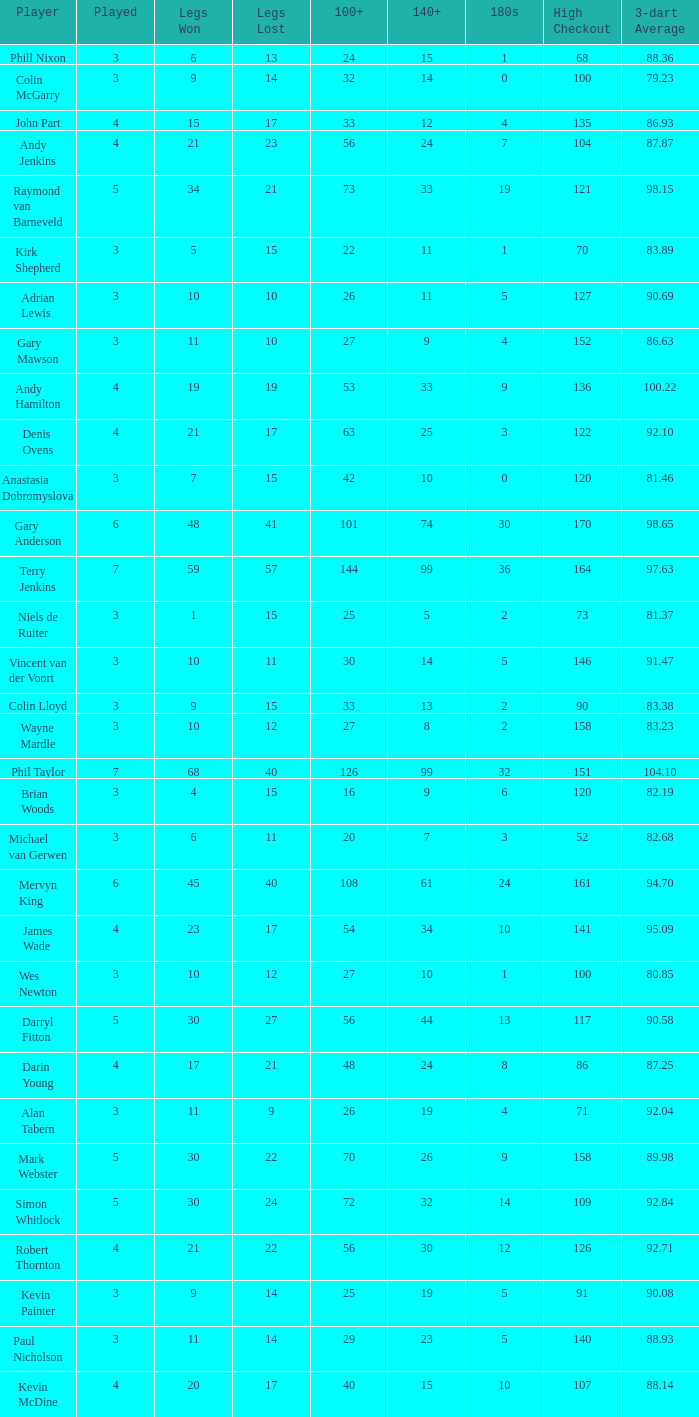What is the high checkout when Legs Won is smaller than 9, a 180s of 1, and a 3-dart Average larger than 88.36? None. Parse the table in full. {'header': ['Player', 'Played', 'Legs Won', 'Legs Lost', '100+', '140+', '180s', 'High Checkout', '3-dart Average'], 'rows': [['Phill Nixon', '3', '6', '13', '24', '15', '1', '68', '88.36'], ['Colin McGarry', '3', '9', '14', '32', '14', '0', '100', '79.23'], ['John Part', '4', '15', '17', '33', '12', '4', '135', '86.93'], ['Andy Jenkins', '4', '21', '23', '56', '24', '7', '104', '87.87'], ['Raymond van Barneveld', '5', '34', '21', '73', '33', '19', '121', '98.15'], ['Kirk Shepherd', '3', '5', '15', '22', '11', '1', '70', '83.89'], ['Adrian Lewis', '3', '10', '10', '26', '11', '5', '127', '90.69'], ['Gary Mawson', '3', '11', '10', '27', '9', '4', '152', '86.63'], ['Andy Hamilton', '4', '19', '19', '53', '33', '9', '136', '100.22'], ['Denis Ovens', '4', '21', '17', '63', '25', '3', '122', '92.10'], ['Anastasia Dobromyslova', '3', '7', '15', '42', '10', '0', '120', '81.46'], ['Gary Anderson', '6', '48', '41', '101', '74', '30', '170', '98.65'], ['Terry Jenkins', '7', '59', '57', '144', '99', '36', '164', '97.63'], ['Niels de Ruiter', '3', '1', '15', '25', '5', '2', '73', '81.37'], ['Vincent van der Voort', '3', '10', '11', '30', '14', '5', '146', '91.47'], ['Colin Lloyd', '3', '9', '15', '33', '13', '2', '90', '83.38'], ['Wayne Mardle', '3', '10', '12', '27', '8', '2', '158', '83.23'], ['Phil Taylor', '7', '68', '40', '126', '99', '32', '151', '104.10'], ['Brian Woods', '3', '4', '15', '16', '9', '6', '120', '82.19'], ['Michael van Gerwen', '3', '6', '11', '20', '7', '3', '52', '82.68'], ['Mervyn King', '6', '45', '40', '108', '61', '24', '161', '94.70'], ['James Wade', '4', '23', '17', '54', '34', '10', '141', '95.09'], ['Wes Newton', '3', '10', '12', '27', '10', '1', '100', '80.85'], ['Darryl Fitton', '5', '30', '27', '56', '44', '13', '117', '90.58'], ['Darin Young', '4', '17', '21', '48', '24', '8', '86', '87.25'], ['Alan Tabern', '3', '11', '9', '26', '19', '4', '71', '92.04'], ['Mark Webster', '5', '30', '22', '70', '26', '9', '158', '89.98'], ['Simon Whitlock', '5', '30', '24', '72', '32', '14', '109', '92.84'], ['Robert Thornton', '4', '21', '22', '56', '30', '12', '126', '92.71'], ['Kevin Painter', '3', '9', '14', '25', '19', '5', '91', '90.08'], ['Paul Nicholson', '3', '11', '14', '29', '23', '5', '140', '88.93'], ['Kevin McDine', '4', '20', '17', '40', '15', '10', '107', '88.14']]} 